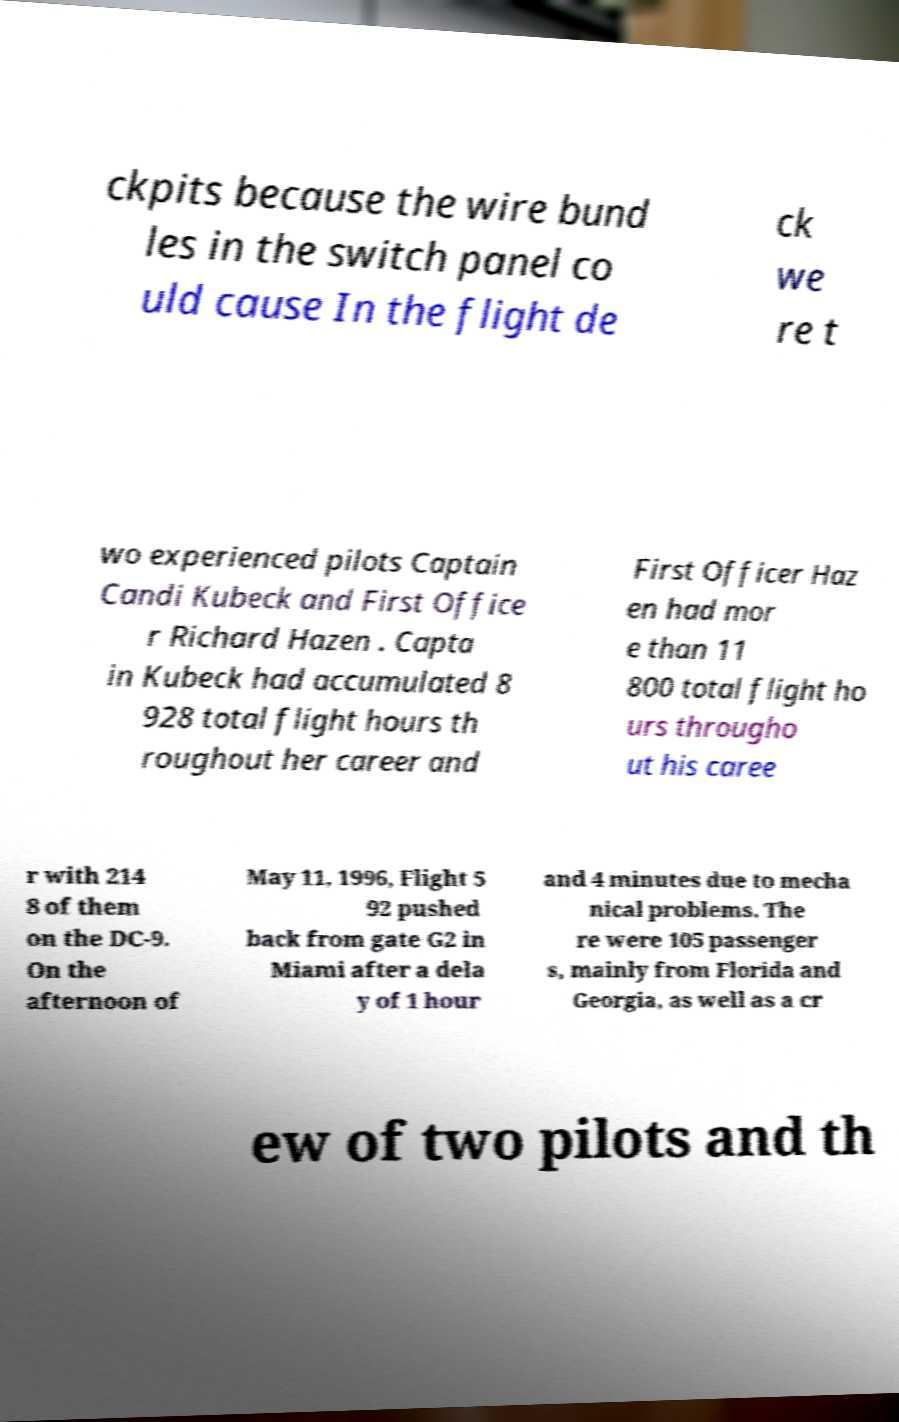Please read and relay the text visible in this image. What does it say? ckpits because the wire bund les in the switch panel co uld cause In the flight de ck we re t wo experienced pilots Captain Candi Kubeck and First Office r Richard Hazen . Capta in Kubeck had accumulated 8 928 total flight hours th roughout her career and First Officer Haz en had mor e than 11 800 total flight ho urs througho ut his caree r with 214 8 of them on the DC-9. On the afternoon of May 11, 1996, Flight 5 92 pushed back from gate G2 in Miami after a dela y of 1 hour and 4 minutes due to mecha nical problems. The re were 105 passenger s, mainly from Florida and Georgia, as well as a cr ew of two pilots and th 